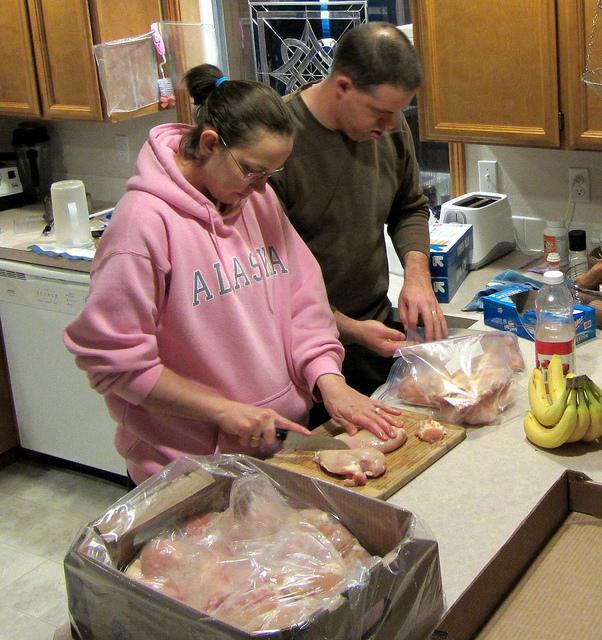How many people are visible?
Give a very brief answer. 2. 